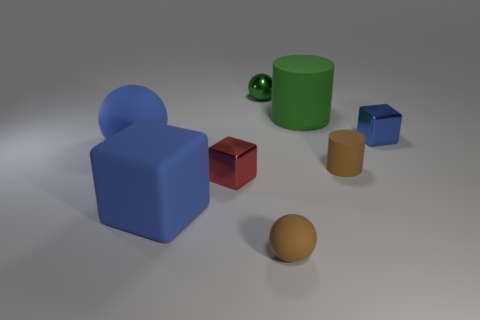Subtract all yellow cylinders. How many blue blocks are left? 2 Add 1 green balls. How many objects exist? 9 Subtract all matte spheres. How many spheres are left? 1 Subtract 1 balls. How many balls are left? 2 Subtract all cylinders. How many objects are left? 6 Add 3 yellow cylinders. How many yellow cylinders exist? 3 Subtract 0 gray cylinders. How many objects are left? 8 Subtract all gray shiny objects. Subtract all green metal things. How many objects are left? 7 Add 4 small shiny objects. How many small shiny objects are left? 7 